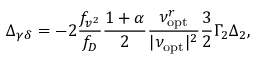<formula> <loc_0><loc_0><loc_500><loc_500>\Delta _ { \gamma \delta } = - 2 \frac { f _ { v ^ { 2 } } } { f _ { D } } \frac { 1 + \alpha } { 2 } \frac { \nu _ { o p t } ^ { r } } { | \nu _ { o p t } | ^ { 2 } } \frac { 3 } { 2 } \Gamma _ { 2 } \Delta _ { 2 } ,</formula> 